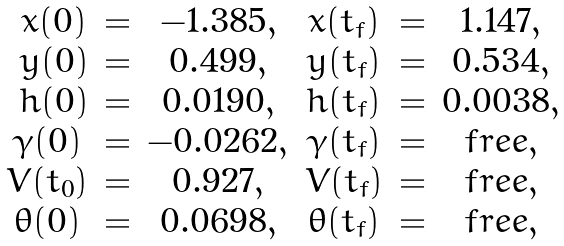Convert formula to latex. <formula><loc_0><loc_0><loc_500><loc_500>\begin{array} { c c c c c c } \ x ( 0 ) & = & - 1 . 3 8 5 , & x ( t _ { f } ) & = & 1 . 1 4 7 , \\ \ y ( 0 ) & = & 0 . 4 9 9 , & y ( t _ { f } ) & = & 0 . 5 3 4 , \\ \ h ( 0 ) & = & 0 . 0 1 9 0 , & h ( t _ { f } ) & = & 0 . 0 0 3 8 , \\ \gamma ( 0 ) & = & - 0 . 0 2 6 2 , & \gamma ( t _ { f } ) & = & f r e e , \\ V ( t _ { 0 } ) & = & 0 . 9 2 7 , & V ( t _ { f } ) & = & f r e e , \\ \theta ( 0 ) & = & 0 . 0 6 9 8 , & \theta ( t _ { f } ) & = & f r e e , \\ \end{array}</formula> 